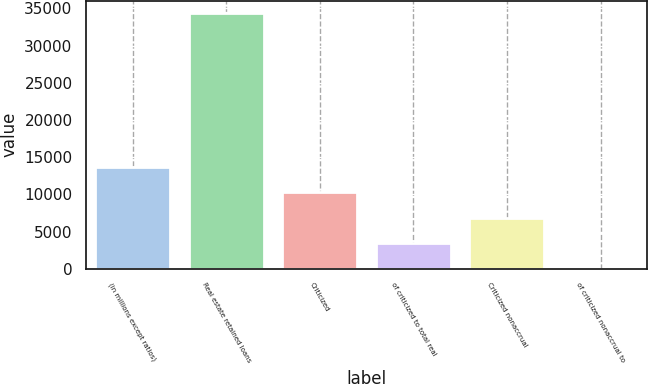Convert chart to OTSL. <chart><loc_0><loc_0><loc_500><loc_500><bar_chart><fcel>(in millions except ratios)<fcel>Real estate retained loans<fcel>Criticized<fcel>of criticized to total real<fcel>Criticized nonaccrual<fcel>of criticized nonaccrual to<nl><fcel>13735.1<fcel>34337<fcel>10301.4<fcel>3434.08<fcel>6867.74<fcel>0.42<nl></chart> 